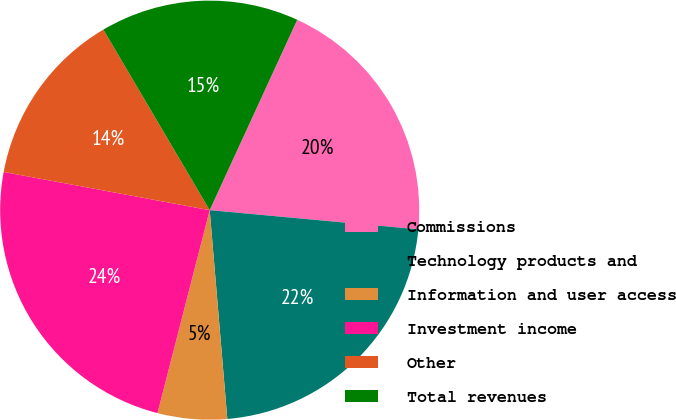<chart> <loc_0><loc_0><loc_500><loc_500><pie_chart><fcel>Commissions<fcel>Technology products and<fcel>Information and user access<fcel>Investment income<fcel>Other<fcel>Total revenues<nl><fcel>19.6%<fcel>22.2%<fcel>5.35%<fcel>23.91%<fcel>13.61%<fcel>15.33%<nl></chart> 